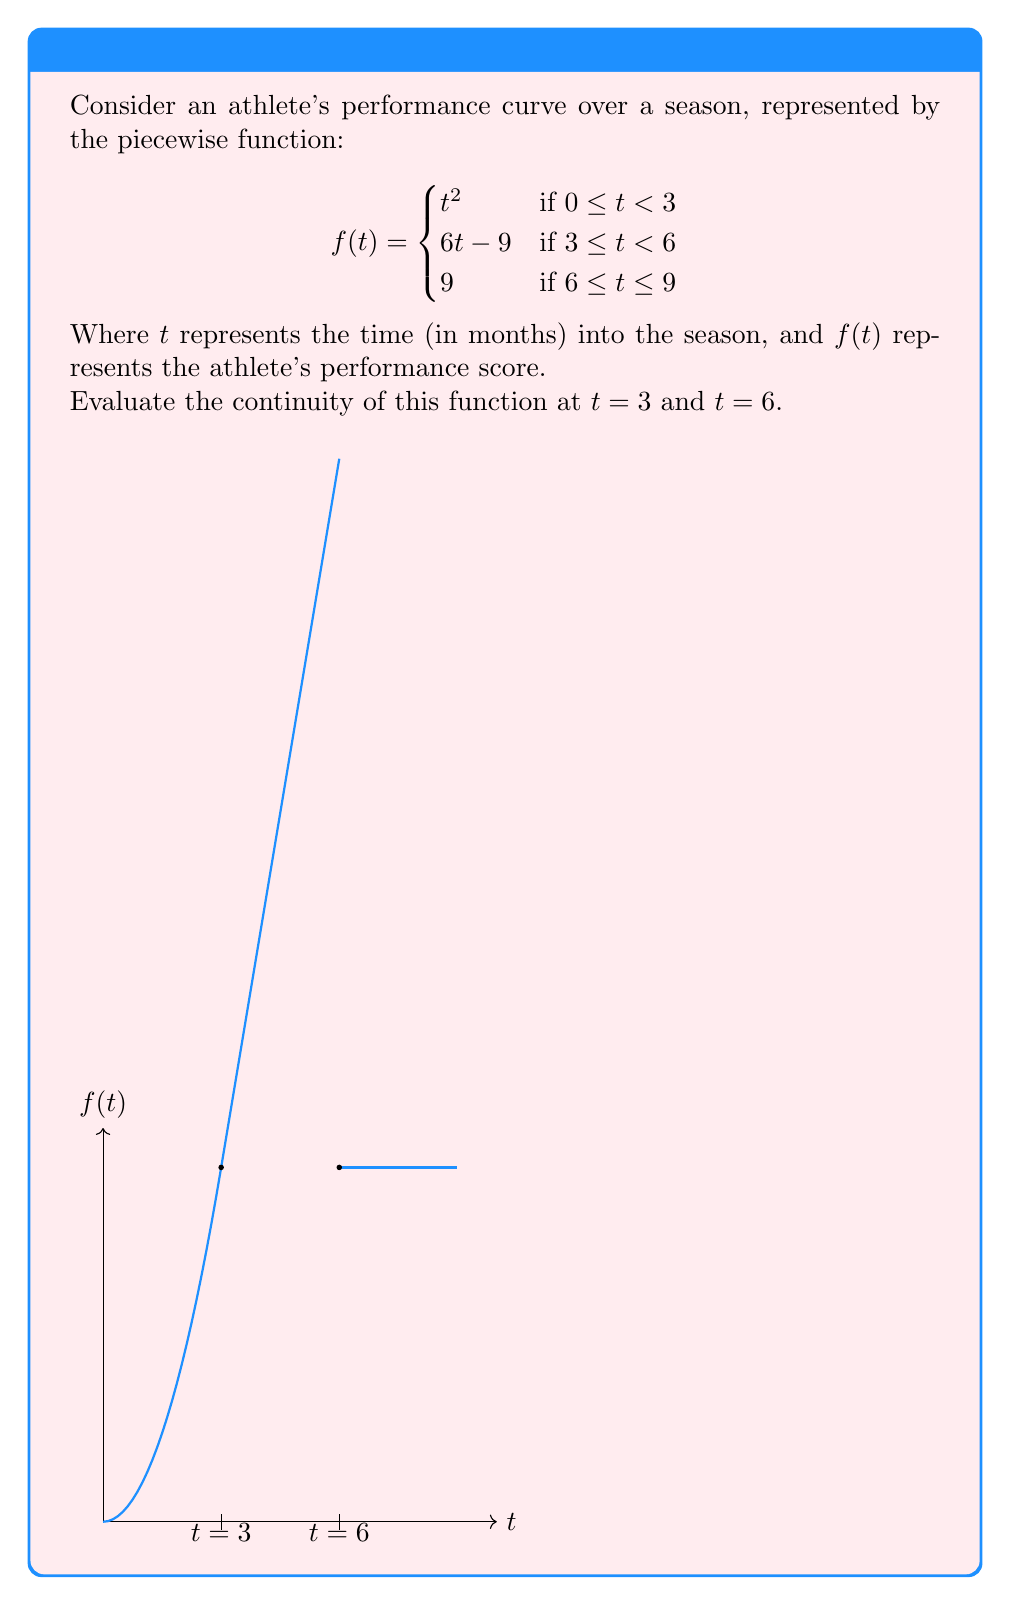Give your solution to this math problem. To evaluate the continuity at $t=3$ and $t=6$, we need to check three conditions at each point:
1. The function is defined at the point.
2. The limit of the function exists as we approach the point from both sides.
3. The limit equals the function value at that point.

For $t=3$:

1. $f(3)$ is defined: $f(3) = 6(3)-9 = 9$
2. Left-hand limit: $\lim_{t \to 3^-} t^2 = 3^2 = 9$
   Right-hand limit: $\lim_{t \to 3^+} (6t-9) = 6(3)-9 = 9$
3. $\lim_{t \to 3} f(t) = f(3) = 9$

All three conditions are satisfied, so $f(t)$ is continuous at $t=3$.

For $t=6$:

1. $f(6)$ is defined: $f(6) = 9$
2. Left-hand limit: $\lim_{t \to 6^-} (6t-9) = 6(6)-9 = 27$
   Right-hand limit: $\lim_{t \to 6^+} 9 = 9$
3. $\lim_{t \to 6^-} f(t) \neq \lim_{t \to 6^+} f(t) \neq f(6)$

The second and third conditions are not met, so $f(t)$ is not continuous at $t=6$.
Answer: Continuous at $t=3$, discontinuous at $t=6$ 